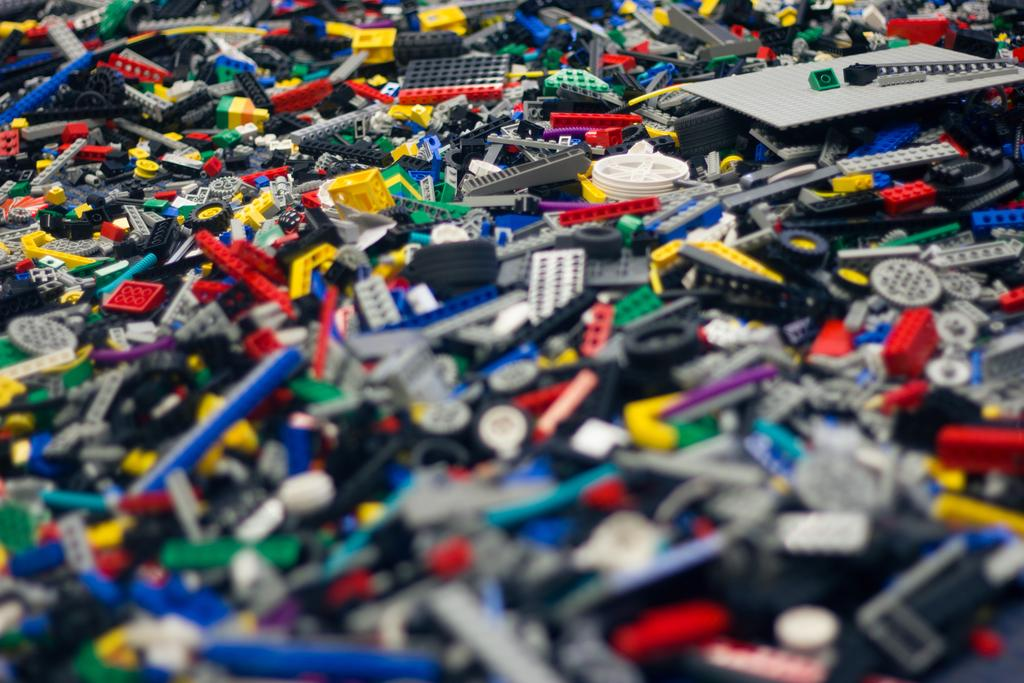What objects are present in the image? There are building blocks in the image. Can you describe the building blocks in more detail? The building blocks are in different colors. Is there a woman wearing a boot in the image? There is no woman or boot present in the image; it only features building blocks in different colors. 